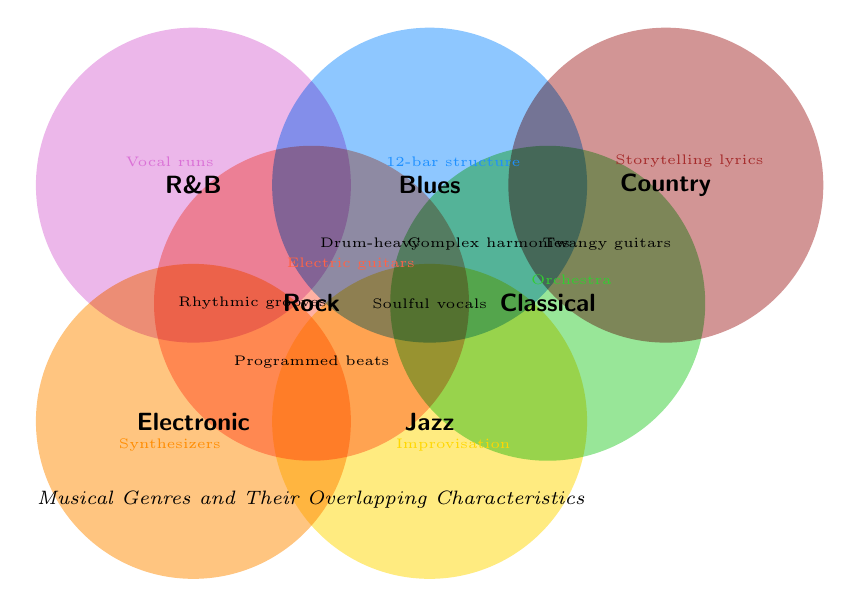What genres overlap with Rock? In the figure, Rock is in the center of several overlapping circles. The genres that overlap with Rock are identified by their positions relative to Rock's circle. "Blues" and "Jazz" overlap with Rock.
Answer: Blues, Jazz Which genre includes the characteristic "Complex harmonies"? The figure lists characteristics inside the circles that represent each genre. "Complex harmonies" is placed inside the Jazz circle.
Answer: Jazz What common characteristics overlap between Blues and Jazz? The figure shows overlapping zones between different genres with characteristics. The overlapping area between Blues and Jazz contains the characteristic "Soulful vocals".
Answer: Soulful vocals Does Electronic music overlap with Country? Examine the position of the Electronic and Country circles in the figure. The circles do not touch or overlap, indicating no shared characteristics.
Answer: No Are "Rhythmic grooves" and "Programmed beats" shared between the same genres? The locations of "Rhythmic grooves" and "Programmed beats" are in different overlapping regions. "Rhythmic grooves" is between R&B and Hip-Hop, while "Programmed beats" is between Electronic and Hip-Hop. They share the Hip-Hop genre but not others.
Answer: No Which genre has the characteristic "Orchestra"? Look at the attributes inside the genre circles. "Orchestra" is placed within the Classical circle.
Answer: Classical What is the most prevalent characteristic among the genres? Count the occurrences of each characteristic within the overlapping zones. "Soulful vocals" appears in multiple overlapping regions including Blues and R&B, making it one of the most common.
Answer: Soulful vocals Which genres feature "Storytelling lyrics"? The placement of "Storytelling lyrics" characteristic inside the Country circle indicates that it is a feature of the Country genre.
Answer: Country What genres overlap with Classical? Consider the genres that intersect with Classical in the figure. Classical overlaps with Jazz and Film Score, indicated by overlapping circles.
Answer: Jazz How many genres have unique (non-overlapping) characteristics? Check for characteristics listed solely within a single genre's circle. Genres with unique characteristics include Classical, Rock, and Blues among others.
Answer: Multiple genres 